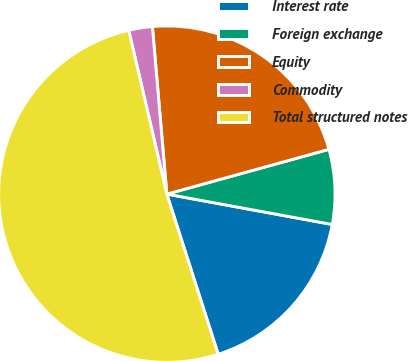Convert chart. <chart><loc_0><loc_0><loc_500><loc_500><pie_chart><fcel>Interest rate<fcel>Foreign exchange<fcel>Equity<fcel>Commodity<fcel>Total structured notes<nl><fcel>17.17%<fcel>7.18%<fcel>22.08%<fcel>2.27%<fcel>51.3%<nl></chart> 